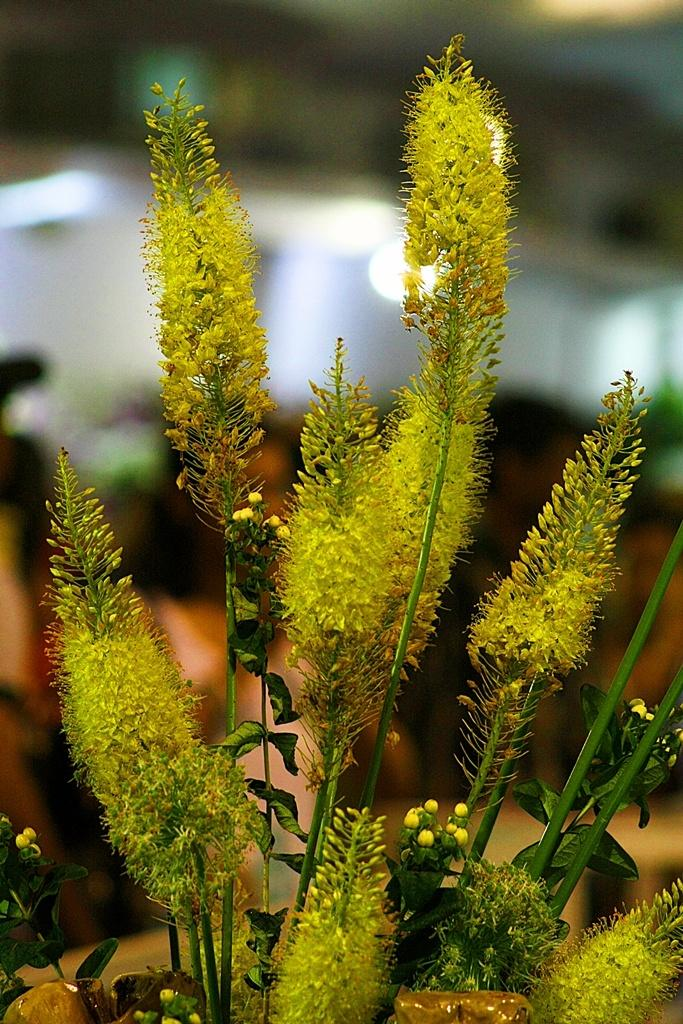What is the main subject in the picture? There is a plant in the picture. Can you describe the background of the image? The background of the image is blurred. What type of ice can be seen melting on the plant in the image? There is no ice present in the image, and therefore no ice can be seen melting on the plant. 